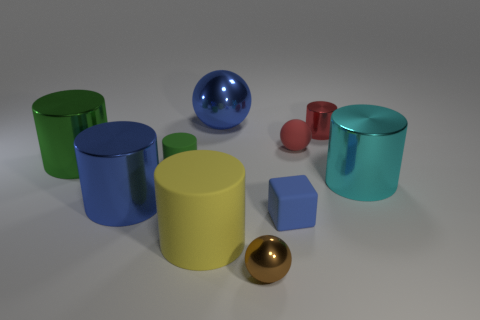How many other objects are there of the same material as the big green cylinder?
Keep it short and to the point. 5. How many big things are balls or cubes?
Your answer should be very brief. 1. Are there the same number of small cylinders to the right of the small brown sphere and large shiny spheres?
Your answer should be very brief. Yes. There is a big shiny cylinder that is in front of the cyan shiny cylinder; is there a big metallic object that is behind it?
Provide a short and direct response. Yes. How many other things are the same color as the small matte sphere?
Provide a succinct answer. 1. The tiny shiny cylinder has what color?
Provide a succinct answer. Red. What is the size of the matte object that is on the left side of the blue block and behind the large yellow rubber cylinder?
Make the answer very short. Small. What number of objects are either small things behind the brown shiny object or cyan cylinders?
Offer a terse response. 5. There is a green object that is made of the same material as the big yellow cylinder; what is its shape?
Your response must be concise. Cylinder. What shape is the tiny blue matte object?
Your answer should be very brief. Cube. 